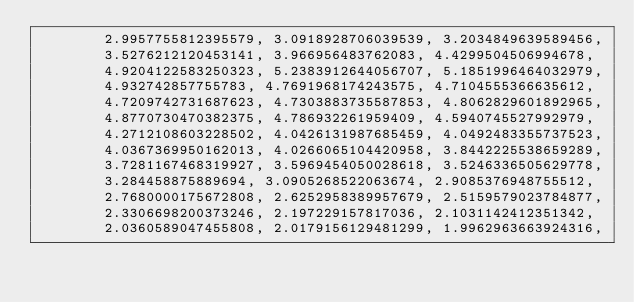<code> <loc_0><loc_0><loc_500><loc_500><_Python_>        2.9957755812395579, 3.0918928706039539, 3.2034849639589456,
        3.5276212120453141, 3.966956483762083, 4.4299504506994678,
        4.9204122583250323, 5.2383912644056707, 5.1851996464032979,
        4.932742857755783, 4.7691968174243575, 4.7104555366635612,
        4.7209742731687623, 4.7303883735587853, 4.8062829601892965,
        4.8770730470382375, 4.786932261959409, 4.5940745527992979,
        4.2712108603228502, 4.0426131987685459, 4.0492483355737523,
        4.0367369950162013, 4.0266065104420958, 3.8442225538659289,
        3.7281167468319927, 3.5969454050028618, 3.5246336505629778,
        3.284458875889694, 3.0905268522063674, 2.9085376948755512,
        2.7680000175672808, 2.6252958389957679, 2.5159579023784877,
        2.3306698200373246, 2.197229157817036, 2.1031142412351342,
        2.0360589047455808, 2.0179156129481299, 1.9962963663924316,</code> 